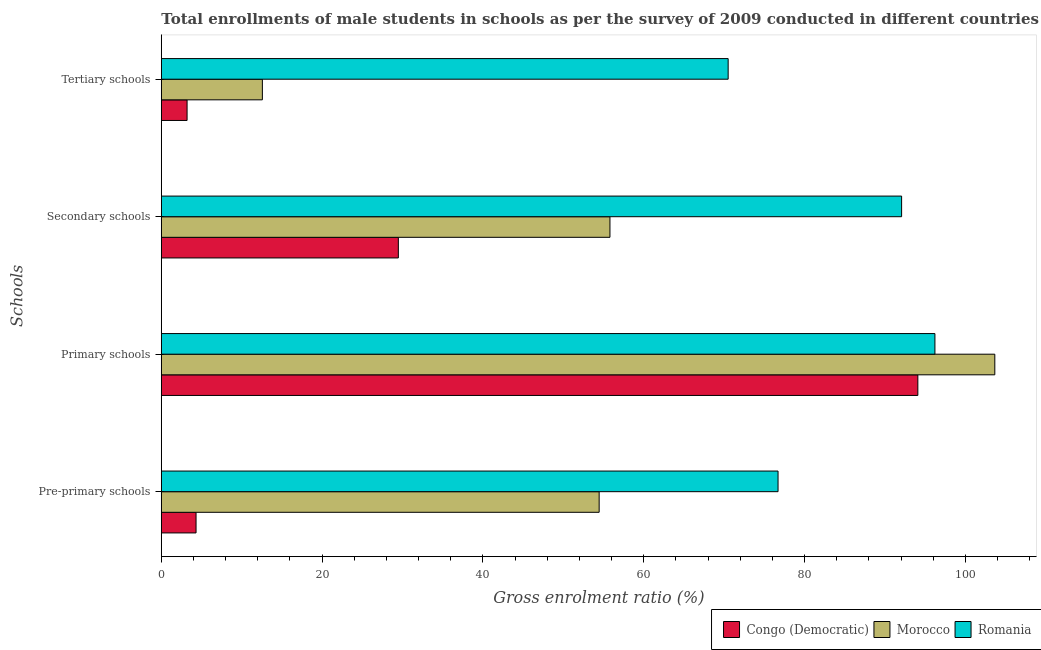How many groups of bars are there?
Offer a terse response. 4. Are the number of bars per tick equal to the number of legend labels?
Your answer should be compact. Yes. Are the number of bars on each tick of the Y-axis equal?
Your answer should be compact. Yes. What is the label of the 3rd group of bars from the top?
Your answer should be compact. Primary schools. What is the gross enrolment ratio(male) in tertiary schools in Romania?
Make the answer very short. 70.5. Across all countries, what is the maximum gross enrolment ratio(male) in tertiary schools?
Your response must be concise. 70.5. Across all countries, what is the minimum gross enrolment ratio(male) in pre-primary schools?
Your answer should be compact. 4.32. In which country was the gross enrolment ratio(male) in pre-primary schools maximum?
Give a very brief answer. Romania. In which country was the gross enrolment ratio(male) in pre-primary schools minimum?
Provide a short and direct response. Congo (Democratic). What is the total gross enrolment ratio(male) in secondary schools in the graph?
Make the answer very short. 177.35. What is the difference between the gross enrolment ratio(male) in secondary schools in Morocco and that in Congo (Democratic)?
Ensure brevity in your answer.  26.32. What is the difference between the gross enrolment ratio(male) in primary schools in Congo (Democratic) and the gross enrolment ratio(male) in pre-primary schools in Romania?
Offer a very short reply. 17.39. What is the average gross enrolment ratio(male) in pre-primary schools per country?
Offer a very short reply. 45.16. What is the difference between the gross enrolment ratio(male) in tertiary schools and gross enrolment ratio(male) in pre-primary schools in Romania?
Your answer should be compact. -6.2. In how many countries, is the gross enrolment ratio(male) in primary schools greater than 52 %?
Provide a succinct answer. 3. What is the ratio of the gross enrolment ratio(male) in secondary schools in Romania to that in Congo (Democratic)?
Ensure brevity in your answer.  3.12. Is the gross enrolment ratio(male) in primary schools in Morocco less than that in Congo (Democratic)?
Your response must be concise. No. What is the difference between the highest and the second highest gross enrolment ratio(male) in tertiary schools?
Provide a succinct answer. 57.93. What is the difference between the highest and the lowest gross enrolment ratio(male) in primary schools?
Offer a terse response. 9.57. In how many countries, is the gross enrolment ratio(male) in primary schools greater than the average gross enrolment ratio(male) in primary schools taken over all countries?
Offer a terse response. 1. What does the 1st bar from the top in Pre-primary schools represents?
Provide a short and direct response. Romania. What does the 3rd bar from the bottom in Tertiary schools represents?
Ensure brevity in your answer.  Romania. Is it the case that in every country, the sum of the gross enrolment ratio(male) in pre-primary schools and gross enrolment ratio(male) in primary schools is greater than the gross enrolment ratio(male) in secondary schools?
Make the answer very short. Yes. How many bars are there?
Make the answer very short. 12. What is the difference between two consecutive major ticks on the X-axis?
Give a very brief answer. 20. Does the graph contain any zero values?
Make the answer very short. No. What is the title of the graph?
Your answer should be compact. Total enrollments of male students in schools as per the survey of 2009 conducted in different countries. Does "Bolivia" appear as one of the legend labels in the graph?
Keep it short and to the point. No. What is the label or title of the X-axis?
Make the answer very short. Gross enrolment ratio (%). What is the label or title of the Y-axis?
Provide a short and direct response. Schools. What is the Gross enrolment ratio (%) of Congo (Democratic) in Pre-primary schools?
Provide a short and direct response. 4.32. What is the Gross enrolment ratio (%) in Morocco in Pre-primary schools?
Your response must be concise. 54.46. What is the Gross enrolment ratio (%) of Romania in Pre-primary schools?
Give a very brief answer. 76.7. What is the Gross enrolment ratio (%) of Congo (Democratic) in Primary schools?
Ensure brevity in your answer.  94.09. What is the Gross enrolment ratio (%) of Morocco in Primary schools?
Provide a succinct answer. 103.66. What is the Gross enrolment ratio (%) of Romania in Primary schools?
Keep it short and to the point. 96.21. What is the Gross enrolment ratio (%) of Congo (Democratic) in Secondary schools?
Ensure brevity in your answer.  29.48. What is the Gross enrolment ratio (%) in Morocco in Secondary schools?
Your response must be concise. 55.8. What is the Gross enrolment ratio (%) of Romania in Secondary schools?
Ensure brevity in your answer.  92.07. What is the Gross enrolment ratio (%) of Congo (Democratic) in Tertiary schools?
Your answer should be very brief. 3.2. What is the Gross enrolment ratio (%) in Morocco in Tertiary schools?
Ensure brevity in your answer.  12.57. What is the Gross enrolment ratio (%) in Romania in Tertiary schools?
Ensure brevity in your answer.  70.5. Across all Schools, what is the maximum Gross enrolment ratio (%) of Congo (Democratic)?
Offer a terse response. 94.09. Across all Schools, what is the maximum Gross enrolment ratio (%) in Morocco?
Give a very brief answer. 103.66. Across all Schools, what is the maximum Gross enrolment ratio (%) in Romania?
Your response must be concise. 96.21. Across all Schools, what is the minimum Gross enrolment ratio (%) of Congo (Democratic)?
Your response must be concise. 3.2. Across all Schools, what is the minimum Gross enrolment ratio (%) of Morocco?
Your answer should be very brief. 12.57. Across all Schools, what is the minimum Gross enrolment ratio (%) of Romania?
Your answer should be very brief. 70.5. What is the total Gross enrolment ratio (%) of Congo (Democratic) in the graph?
Your answer should be compact. 131.09. What is the total Gross enrolment ratio (%) in Morocco in the graph?
Your response must be concise. 226.49. What is the total Gross enrolment ratio (%) of Romania in the graph?
Ensure brevity in your answer.  335.49. What is the difference between the Gross enrolment ratio (%) of Congo (Democratic) in Pre-primary schools and that in Primary schools?
Provide a short and direct response. -89.77. What is the difference between the Gross enrolment ratio (%) in Morocco in Pre-primary schools and that in Primary schools?
Keep it short and to the point. -49.21. What is the difference between the Gross enrolment ratio (%) of Romania in Pre-primary schools and that in Primary schools?
Make the answer very short. -19.51. What is the difference between the Gross enrolment ratio (%) of Congo (Democratic) in Pre-primary schools and that in Secondary schools?
Keep it short and to the point. -25.16. What is the difference between the Gross enrolment ratio (%) in Morocco in Pre-primary schools and that in Secondary schools?
Your answer should be compact. -1.34. What is the difference between the Gross enrolment ratio (%) in Romania in Pre-primary schools and that in Secondary schools?
Offer a terse response. -15.37. What is the difference between the Gross enrolment ratio (%) in Congo (Democratic) in Pre-primary schools and that in Tertiary schools?
Provide a short and direct response. 1.12. What is the difference between the Gross enrolment ratio (%) in Morocco in Pre-primary schools and that in Tertiary schools?
Provide a succinct answer. 41.89. What is the difference between the Gross enrolment ratio (%) in Romania in Pre-primary schools and that in Tertiary schools?
Your answer should be compact. 6.2. What is the difference between the Gross enrolment ratio (%) of Congo (Democratic) in Primary schools and that in Secondary schools?
Give a very brief answer. 64.61. What is the difference between the Gross enrolment ratio (%) in Morocco in Primary schools and that in Secondary schools?
Provide a succinct answer. 47.87. What is the difference between the Gross enrolment ratio (%) of Romania in Primary schools and that in Secondary schools?
Give a very brief answer. 4.14. What is the difference between the Gross enrolment ratio (%) in Congo (Democratic) in Primary schools and that in Tertiary schools?
Ensure brevity in your answer.  90.89. What is the difference between the Gross enrolment ratio (%) of Morocco in Primary schools and that in Tertiary schools?
Keep it short and to the point. 91.1. What is the difference between the Gross enrolment ratio (%) in Romania in Primary schools and that in Tertiary schools?
Your answer should be compact. 25.72. What is the difference between the Gross enrolment ratio (%) of Congo (Democratic) in Secondary schools and that in Tertiary schools?
Offer a terse response. 26.28. What is the difference between the Gross enrolment ratio (%) of Morocco in Secondary schools and that in Tertiary schools?
Your answer should be compact. 43.23. What is the difference between the Gross enrolment ratio (%) of Romania in Secondary schools and that in Tertiary schools?
Offer a terse response. 21.57. What is the difference between the Gross enrolment ratio (%) in Congo (Democratic) in Pre-primary schools and the Gross enrolment ratio (%) in Morocco in Primary schools?
Provide a short and direct response. -99.34. What is the difference between the Gross enrolment ratio (%) in Congo (Democratic) in Pre-primary schools and the Gross enrolment ratio (%) in Romania in Primary schools?
Provide a succinct answer. -91.9. What is the difference between the Gross enrolment ratio (%) of Morocco in Pre-primary schools and the Gross enrolment ratio (%) of Romania in Primary schools?
Make the answer very short. -41.76. What is the difference between the Gross enrolment ratio (%) in Congo (Democratic) in Pre-primary schools and the Gross enrolment ratio (%) in Morocco in Secondary schools?
Offer a very short reply. -51.48. What is the difference between the Gross enrolment ratio (%) in Congo (Democratic) in Pre-primary schools and the Gross enrolment ratio (%) in Romania in Secondary schools?
Provide a succinct answer. -87.75. What is the difference between the Gross enrolment ratio (%) in Morocco in Pre-primary schools and the Gross enrolment ratio (%) in Romania in Secondary schools?
Ensure brevity in your answer.  -37.62. What is the difference between the Gross enrolment ratio (%) in Congo (Democratic) in Pre-primary schools and the Gross enrolment ratio (%) in Morocco in Tertiary schools?
Give a very brief answer. -8.25. What is the difference between the Gross enrolment ratio (%) of Congo (Democratic) in Pre-primary schools and the Gross enrolment ratio (%) of Romania in Tertiary schools?
Provide a short and direct response. -66.18. What is the difference between the Gross enrolment ratio (%) in Morocco in Pre-primary schools and the Gross enrolment ratio (%) in Romania in Tertiary schools?
Offer a very short reply. -16.04. What is the difference between the Gross enrolment ratio (%) in Congo (Democratic) in Primary schools and the Gross enrolment ratio (%) in Morocco in Secondary schools?
Your answer should be compact. 38.29. What is the difference between the Gross enrolment ratio (%) of Congo (Democratic) in Primary schools and the Gross enrolment ratio (%) of Romania in Secondary schools?
Ensure brevity in your answer.  2.02. What is the difference between the Gross enrolment ratio (%) of Morocco in Primary schools and the Gross enrolment ratio (%) of Romania in Secondary schools?
Give a very brief answer. 11.59. What is the difference between the Gross enrolment ratio (%) in Congo (Democratic) in Primary schools and the Gross enrolment ratio (%) in Morocco in Tertiary schools?
Provide a succinct answer. 81.52. What is the difference between the Gross enrolment ratio (%) of Congo (Democratic) in Primary schools and the Gross enrolment ratio (%) of Romania in Tertiary schools?
Provide a succinct answer. 23.59. What is the difference between the Gross enrolment ratio (%) in Morocco in Primary schools and the Gross enrolment ratio (%) in Romania in Tertiary schools?
Give a very brief answer. 33.16. What is the difference between the Gross enrolment ratio (%) in Congo (Democratic) in Secondary schools and the Gross enrolment ratio (%) in Morocco in Tertiary schools?
Provide a short and direct response. 16.91. What is the difference between the Gross enrolment ratio (%) of Congo (Democratic) in Secondary schools and the Gross enrolment ratio (%) of Romania in Tertiary schools?
Give a very brief answer. -41.02. What is the difference between the Gross enrolment ratio (%) in Morocco in Secondary schools and the Gross enrolment ratio (%) in Romania in Tertiary schools?
Make the answer very short. -14.7. What is the average Gross enrolment ratio (%) of Congo (Democratic) per Schools?
Give a very brief answer. 32.77. What is the average Gross enrolment ratio (%) in Morocco per Schools?
Your answer should be compact. 56.62. What is the average Gross enrolment ratio (%) of Romania per Schools?
Your answer should be compact. 83.87. What is the difference between the Gross enrolment ratio (%) of Congo (Democratic) and Gross enrolment ratio (%) of Morocco in Pre-primary schools?
Offer a terse response. -50.14. What is the difference between the Gross enrolment ratio (%) in Congo (Democratic) and Gross enrolment ratio (%) in Romania in Pre-primary schools?
Ensure brevity in your answer.  -72.38. What is the difference between the Gross enrolment ratio (%) in Morocco and Gross enrolment ratio (%) in Romania in Pre-primary schools?
Make the answer very short. -22.25. What is the difference between the Gross enrolment ratio (%) of Congo (Democratic) and Gross enrolment ratio (%) of Morocco in Primary schools?
Offer a very short reply. -9.57. What is the difference between the Gross enrolment ratio (%) in Congo (Democratic) and Gross enrolment ratio (%) in Romania in Primary schools?
Your answer should be very brief. -2.12. What is the difference between the Gross enrolment ratio (%) in Morocco and Gross enrolment ratio (%) in Romania in Primary schools?
Your response must be concise. 7.45. What is the difference between the Gross enrolment ratio (%) in Congo (Democratic) and Gross enrolment ratio (%) in Morocco in Secondary schools?
Provide a succinct answer. -26.32. What is the difference between the Gross enrolment ratio (%) in Congo (Democratic) and Gross enrolment ratio (%) in Romania in Secondary schools?
Provide a short and direct response. -62.59. What is the difference between the Gross enrolment ratio (%) of Morocco and Gross enrolment ratio (%) of Romania in Secondary schools?
Make the answer very short. -36.27. What is the difference between the Gross enrolment ratio (%) of Congo (Democratic) and Gross enrolment ratio (%) of Morocco in Tertiary schools?
Give a very brief answer. -9.36. What is the difference between the Gross enrolment ratio (%) in Congo (Democratic) and Gross enrolment ratio (%) in Romania in Tertiary schools?
Provide a short and direct response. -67.3. What is the difference between the Gross enrolment ratio (%) in Morocco and Gross enrolment ratio (%) in Romania in Tertiary schools?
Provide a succinct answer. -57.93. What is the ratio of the Gross enrolment ratio (%) in Congo (Democratic) in Pre-primary schools to that in Primary schools?
Ensure brevity in your answer.  0.05. What is the ratio of the Gross enrolment ratio (%) of Morocco in Pre-primary schools to that in Primary schools?
Provide a succinct answer. 0.53. What is the ratio of the Gross enrolment ratio (%) in Romania in Pre-primary schools to that in Primary schools?
Keep it short and to the point. 0.8. What is the ratio of the Gross enrolment ratio (%) in Congo (Democratic) in Pre-primary schools to that in Secondary schools?
Keep it short and to the point. 0.15. What is the ratio of the Gross enrolment ratio (%) in Morocco in Pre-primary schools to that in Secondary schools?
Your answer should be very brief. 0.98. What is the ratio of the Gross enrolment ratio (%) of Romania in Pre-primary schools to that in Secondary schools?
Keep it short and to the point. 0.83. What is the ratio of the Gross enrolment ratio (%) of Congo (Democratic) in Pre-primary schools to that in Tertiary schools?
Give a very brief answer. 1.35. What is the ratio of the Gross enrolment ratio (%) in Morocco in Pre-primary schools to that in Tertiary schools?
Ensure brevity in your answer.  4.33. What is the ratio of the Gross enrolment ratio (%) in Romania in Pre-primary schools to that in Tertiary schools?
Offer a terse response. 1.09. What is the ratio of the Gross enrolment ratio (%) of Congo (Democratic) in Primary schools to that in Secondary schools?
Give a very brief answer. 3.19. What is the ratio of the Gross enrolment ratio (%) in Morocco in Primary schools to that in Secondary schools?
Your answer should be very brief. 1.86. What is the ratio of the Gross enrolment ratio (%) of Romania in Primary schools to that in Secondary schools?
Your answer should be very brief. 1.04. What is the ratio of the Gross enrolment ratio (%) of Congo (Democratic) in Primary schools to that in Tertiary schools?
Offer a very short reply. 29.37. What is the ratio of the Gross enrolment ratio (%) in Morocco in Primary schools to that in Tertiary schools?
Offer a terse response. 8.25. What is the ratio of the Gross enrolment ratio (%) of Romania in Primary schools to that in Tertiary schools?
Your answer should be very brief. 1.36. What is the ratio of the Gross enrolment ratio (%) of Congo (Democratic) in Secondary schools to that in Tertiary schools?
Your answer should be compact. 9.2. What is the ratio of the Gross enrolment ratio (%) in Morocco in Secondary schools to that in Tertiary schools?
Your response must be concise. 4.44. What is the ratio of the Gross enrolment ratio (%) in Romania in Secondary schools to that in Tertiary schools?
Keep it short and to the point. 1.31. What is the difference between the highest and the second highest Gross enrolment ratio (%) in Congo (Democratic)?
Provide a succinct answer. 64.61. What is the difference between the highest and the second highest Gross enrolment ratio (%) in Morocco?
Give a very brief answer. 47.87. What is the difference between the highest and the second highest Gross enrolment ratio (%) of Romania?
Your answer should be very brief. 4.14. What is the difference between the highest and the lowest Gross enrolment ratio (%) of Congo (Democratic)?
Offer a very short reply. 90.89. What is the difference between the highest and the lowest Gross enrolment ratio (%) of Morocco?
Provide a succinct answer. 91.1. What is the difference between the highest and the lowest Gross enrolment ratio (%) of Romania?
Keep it short and to the point. 25.72. 